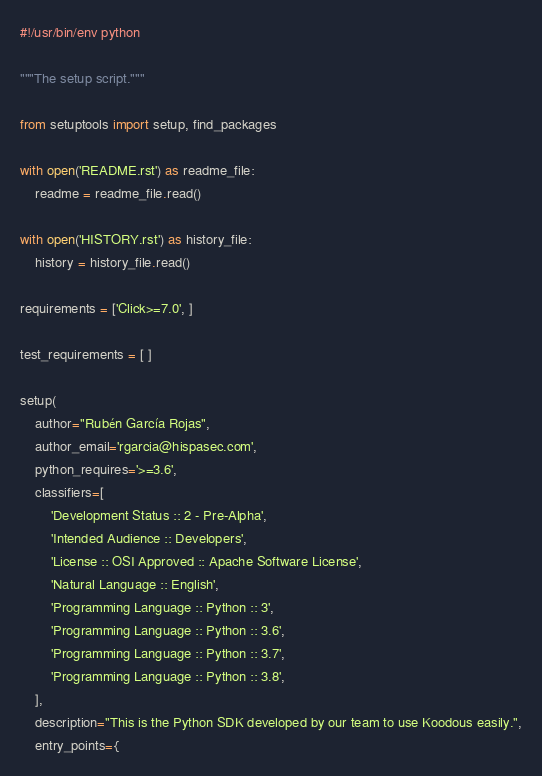Convert code to text. <code><loc_0><loc_0><loc_500><loc_500><_Python_>#!/usr/bin/env python

"""The setup script."""

from setuptools import setup, find_packages

with open('README.rst') as readme_file:
    readme = readme_file.read()

with open('HISTORY.rst') as history_file:
    history = history_file.read()

requirements = ['Click>=7.0', ]

test_requirements = [ ]

setup(
    author="Rubén García Rojas",
    author_email='rgarcia@hispasec.com',
    python_requires='>=3.6',
    classifiers=[
        'Development Status :: 2 - Pre-Alpha',
        'Intended Audience :: Developers',
        'License :: OSI Approved :: Apache Software License',
        'Natural Language :: English',
        'Programming Language :: Python :: 3',
        'Programming Language :: Python :: 3.6',
        'Programming Language :: Python :: 3.7',
        'Programming Language :: Python :: 3.8',
    ],
    description="This is the Python SDK developed by our team to use Koodous easily.",
    entry_points={</code> 